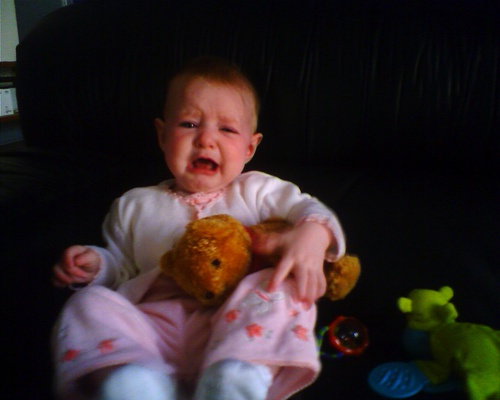Describe the objects in this image and their specific colors. I can see couch in black, gray, maroon, and darkgreen tones, people in gray, black, maroon, darkgray, and brown tones, teddy bear in gray, maroon, brown, and black tones, and teddy bear in gray, black, darkgreen, and olive tones in this image. 